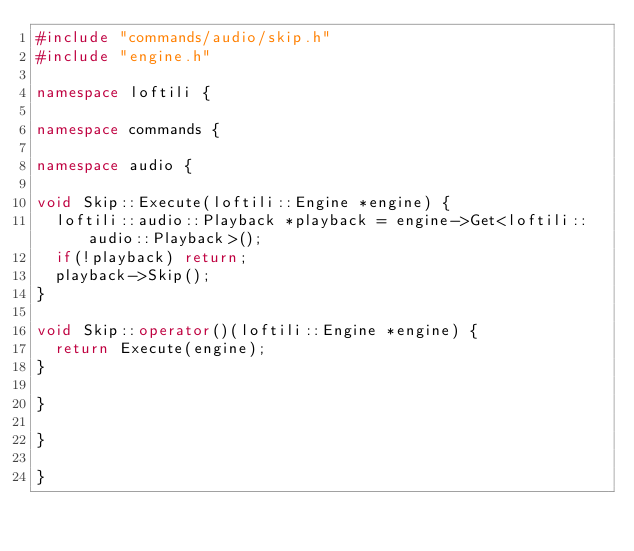<code> <loc_0><loc_0><loc_500><loc_500><_C++_>#include "commands/audio/skip.h"
#include "engine.h"

namespace loftili {

namespace commands {

namespace audio {

void Skip::Execute(loftili::Engine *engine) {
  loftili::audio::Playback *playback = engine->Get<loftili::audio::Playback>();
  if(!playback) return;
  playback->Skip();
}

void Skip::operator()(loftili::Engine *engine) {
  return Execute(engine);
}

}

}

}
</code> 